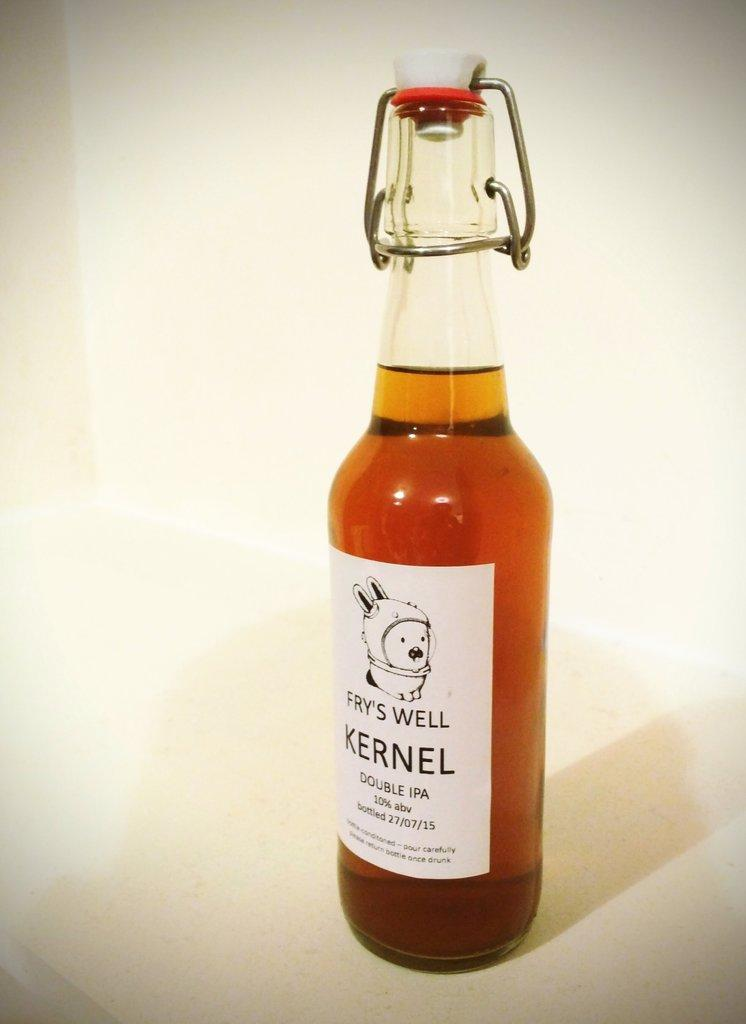What is in the bottle that is visible in the image? There is a drink in the bottle that is visible in the image. Where is the bottle located in the image? The bottle is placed on a table in the image. What can be seen in the background of the image? The background of the image is completely white. What level of belief does the bottle have in the image? The bottle does not have beliefs, as it is an inanimate object. 